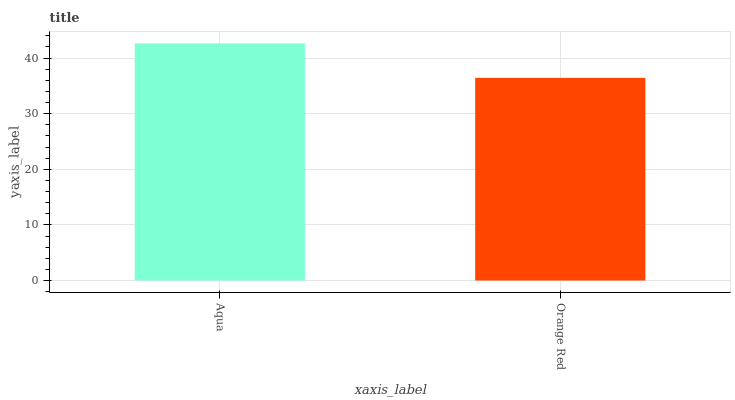Is Orange Red the minimum?
Answer yes or no. Yes. Is Aqua the maximum?
Answer yes or no. Yes. Is Orange Red the maximum?
Answer yes or no. No. Is Aqua greater than Orange Red?
Answer yes or no. Yes. Is Orange Red less than Aqua?
Answer yes or no. Yes. Is Orange Red greater than Aqua?
Answer yes or no. No. Is Aqua less than Orange Red?
Answer yes or no. No. Is Aqua the high median?
Answer yes or no. Yes. Is Orange Red the low median?
Answer yes or no. Yes. Is Orange Red the high median?
Answer yes or no. No. Is Aqua the low median?
Answer yes or no. No. 